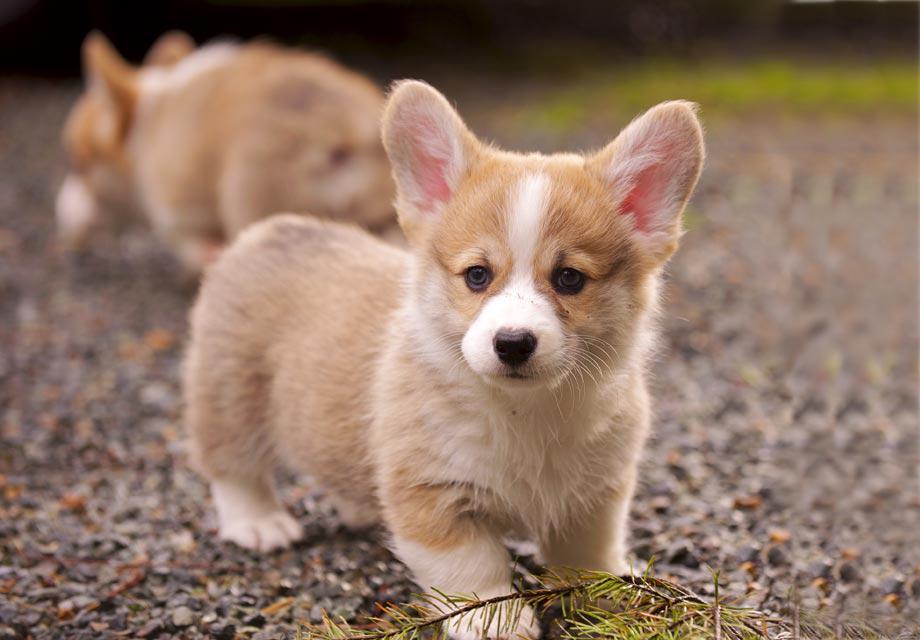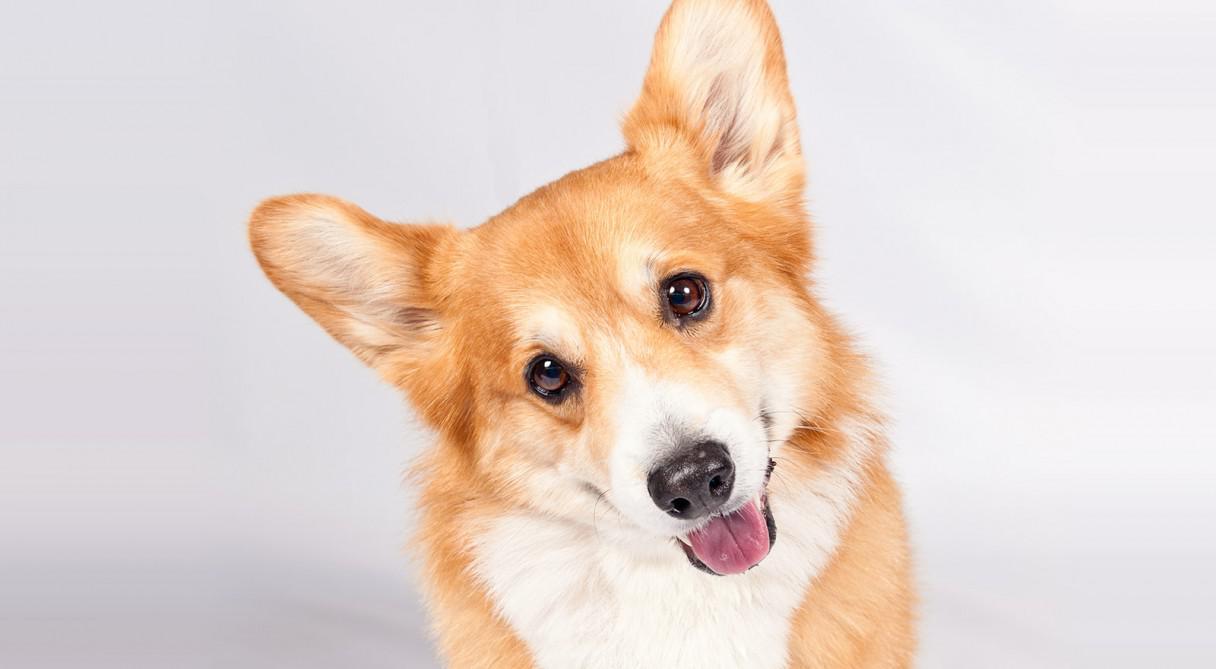The first image is the image on the left, the second image is the image on the right. Examine the images to the left and right. Is the description "There are 3 dogs." accurate? Answer yes or no. Yes. 